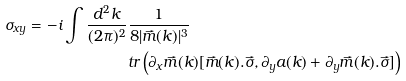<formula> <loc_0><loc_0><loc_500><loc_500>\sigma _ { x y } = - i \int \frac { d ^ { 2 } k } { ( 2 \pi ) ^ { 2 } } & \frac { 1 } { 8 | \vec { m } ( k ) | ^ { 3 } } \\ & t r \left ( \partial _ { x } \vec { m } ( k ) [ \vec { m } ( k ) . \vec { \sigma } , \partial _ { y } a ( k ) + \partial _ { y } \vec { m } ( k ) . \vec { \sigma } ] \right )</formula> 